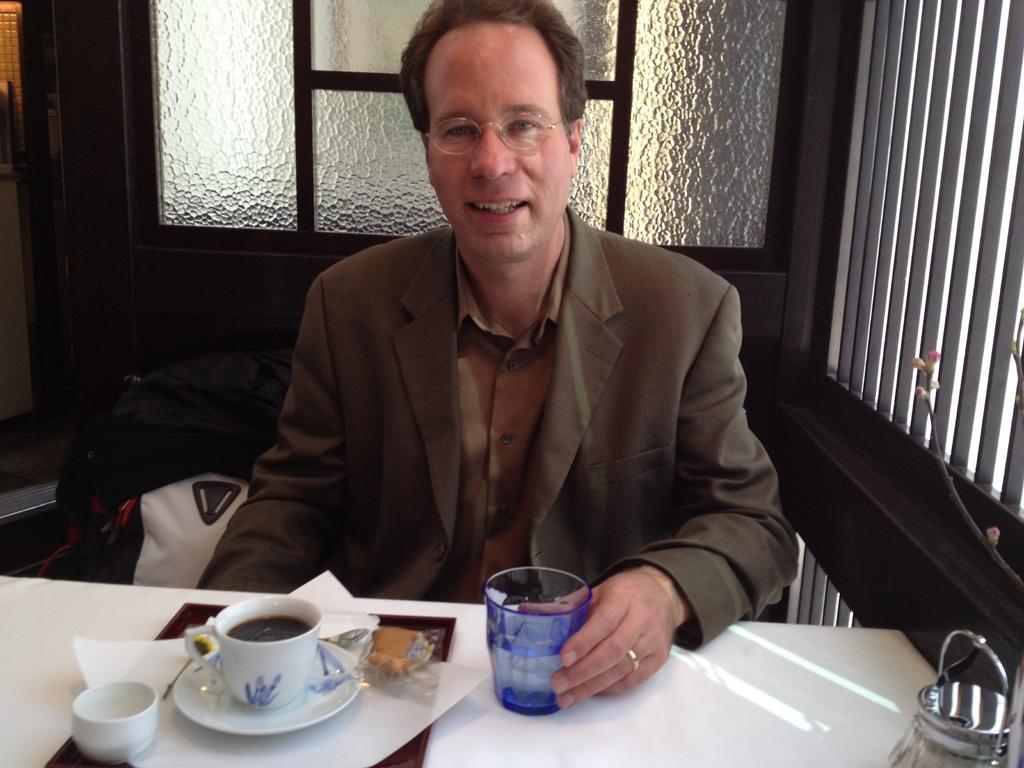Can you describe this image briefly? This man wore suit and sitting on a chair. In-front of this man there is a table, on a table there is a tray, cup, saucer and glass. Backside of this man there is a glass window. 